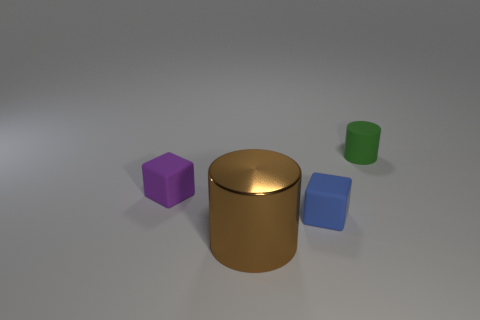Add 2 green things. How many objects exist? 6 Subtract all tiny matte things. Subtract all tiny blue cylinders. How many objects are left? 1 Add 2 small rubber objects. How many small rubber objects are left? 5 Add 2 small cyan cylinders. How many small cyan cylinders exist? 2 Subtract 0 gray blocks. How many objects are left? 4 